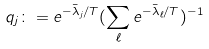<formula> <loc_0><loc_0><loc_500><loc_500>q _ { j } \colon = e ^ { - \bar { \lambda } _ { j } / T } ( \sum _ { \ell } e ^ { - \bar { \lambda } _ { \ell } / T } ) ^ { - 1 }</formula> 